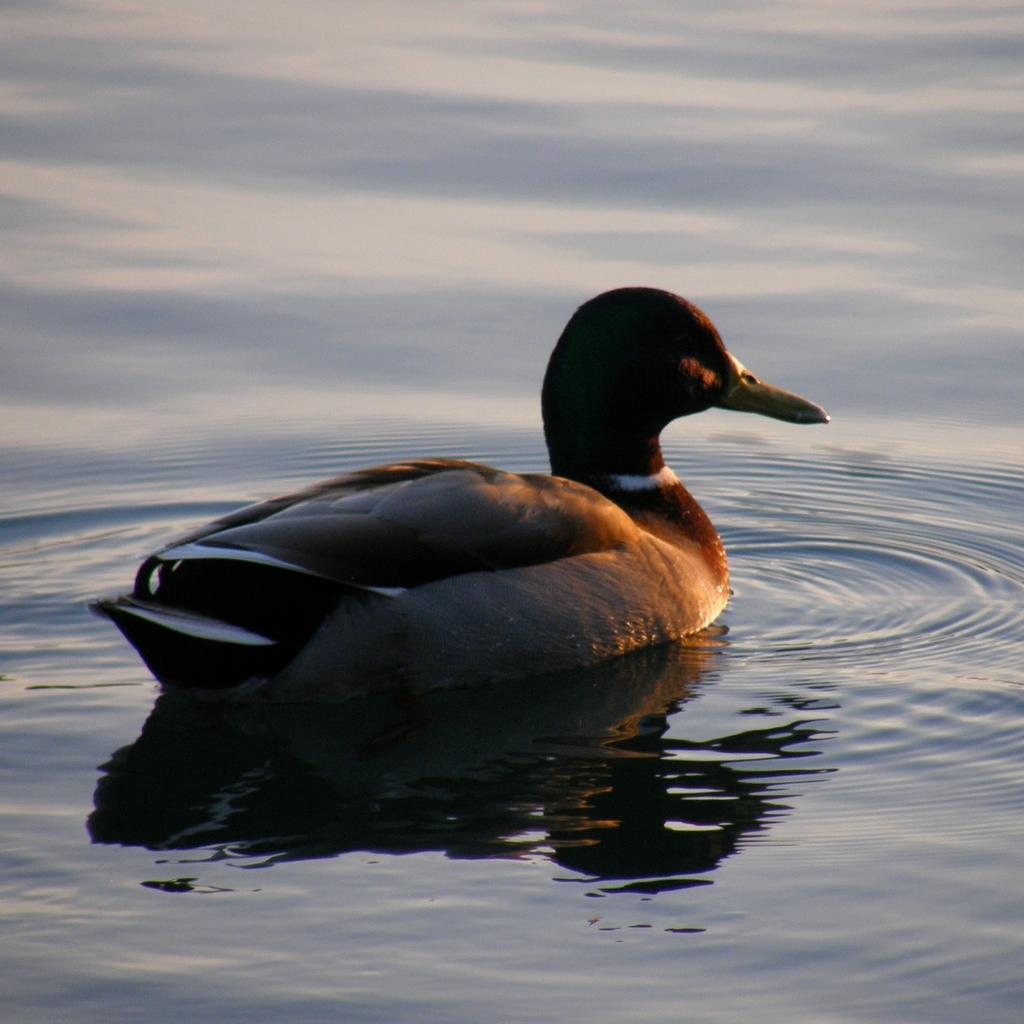What type of animal is in the image? There is an aquatic bird in the image. Where is the bird located in the image? The bird is in the water. What type of plantation can be seen in the background of the image? There is no plantation present in the image; it features an aquatic bird in the water. How many snakes are visible in the image? There are no snakes present in the image; it features an aquatic bird in the water. 